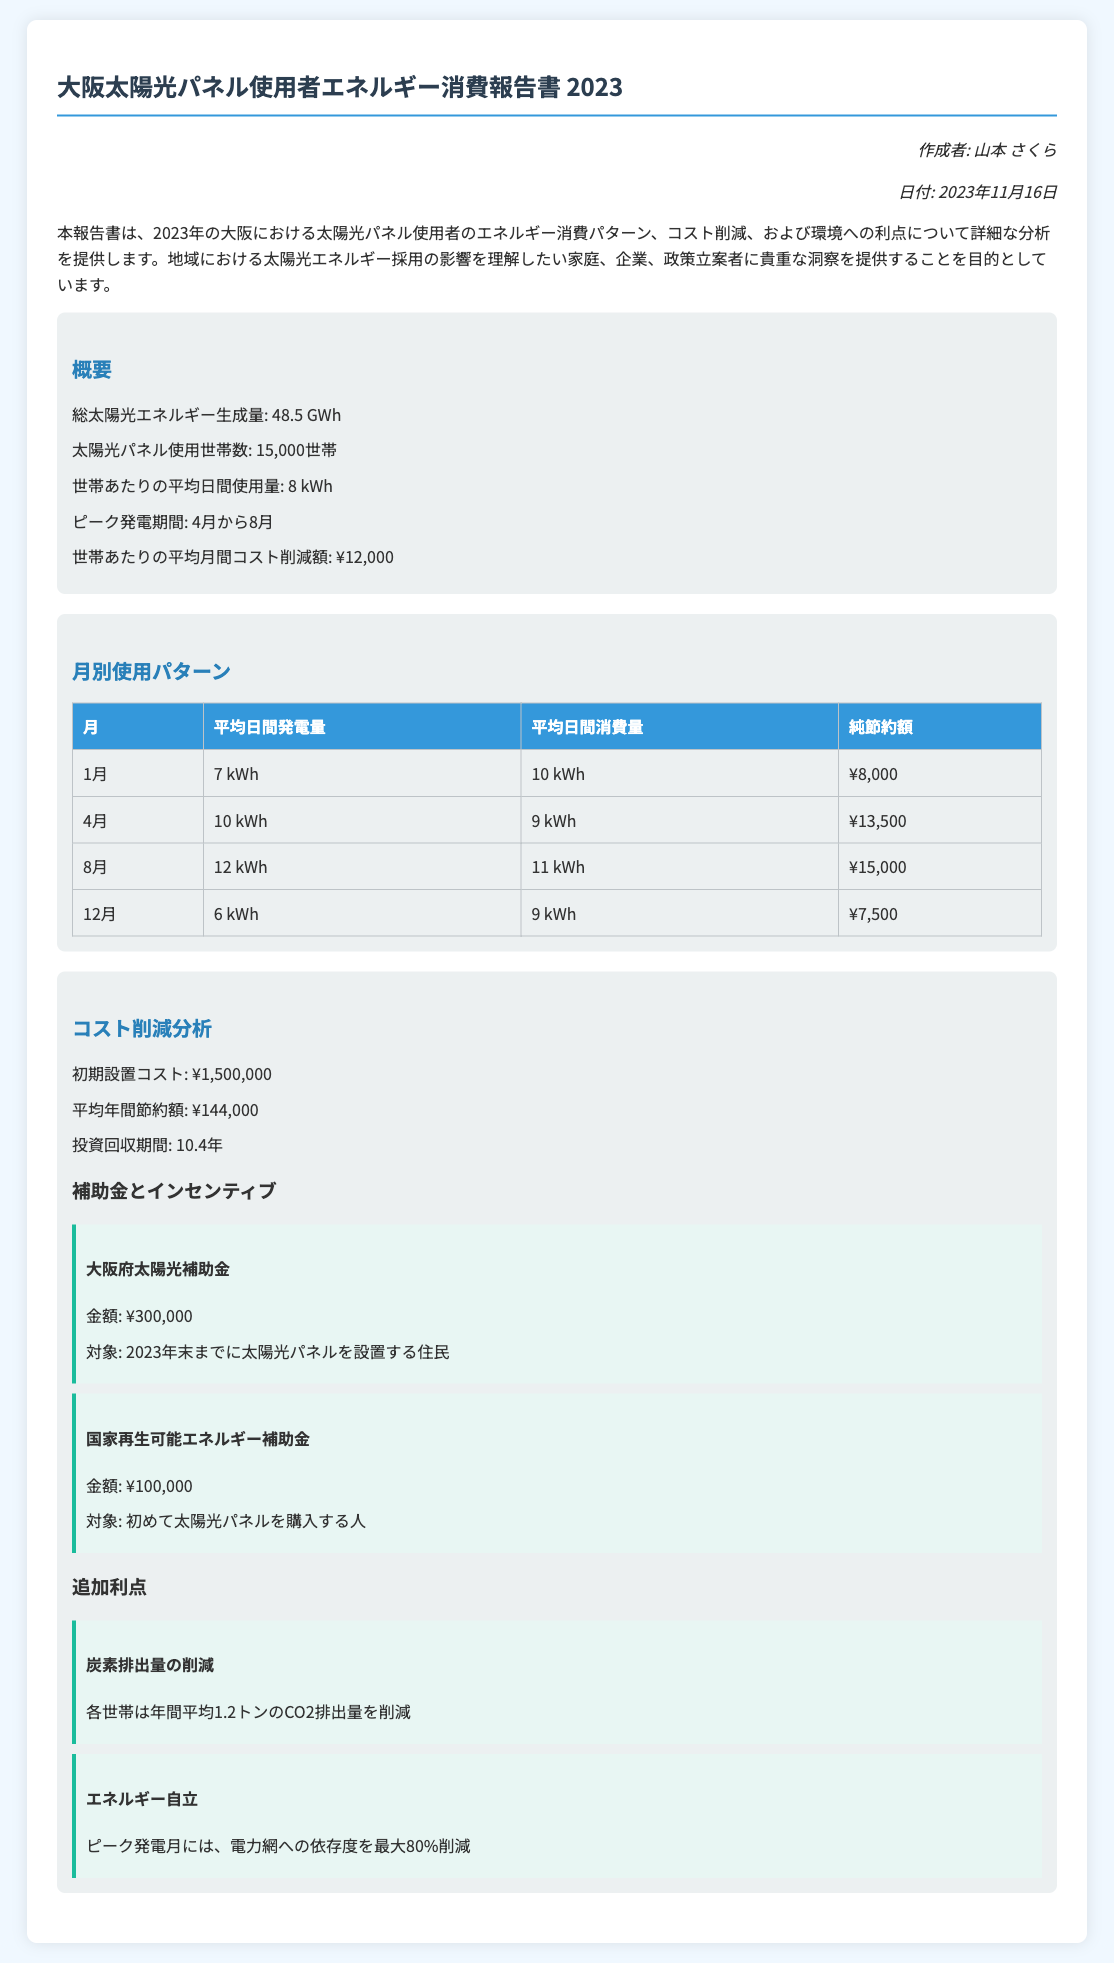何世帯の太陽光パネル使用者がいるか？ 報告書によると、太陽光パネル使用世帯数は15,000世帯である。
Answer: 15,000世帯 2023年の総太陽光エネルギー生成量は？ 概要セクションに記載されている情報によると、2023年の総太陽光エネルギー生成量は48.5 GWhである。
Answer: 48.5 GWh 世帯あたりの平均月間コスト削減額は？ 概要セクションに情報があり、世帯あたりの平均月間コスト削減額は¥12,000とされている。
Answer: ¥12,000 ピーク発電期間はいつか？ 概要セクションには4月から8月がピーク発電期間であると記載されている。
Answer: 4月から8月 初期設置コストは何円か？ コスト削減分析セクションにおいて、初期設置コストは¥1,500,000であると記載されている。
Answer: ¥1,500,000 平均年間節約額は？ コスト削減分析のデータから、平均年間節約額は¥144,000であるとわかる。
Answer: ¥144,000 大阪府太陽光補助金の金額は？ 補助金とインセンティブセクションから、大阪府太陽光補助金の金額は¥300,000である。
Answer: ¥300,000 各世帯は年間平均で何トンのCO2排出量を削減しているか？ 追加利点セクションにより、各世帯は年間平均1.2トンのCO2排出量を削減している。
Answer: 1.2トン 